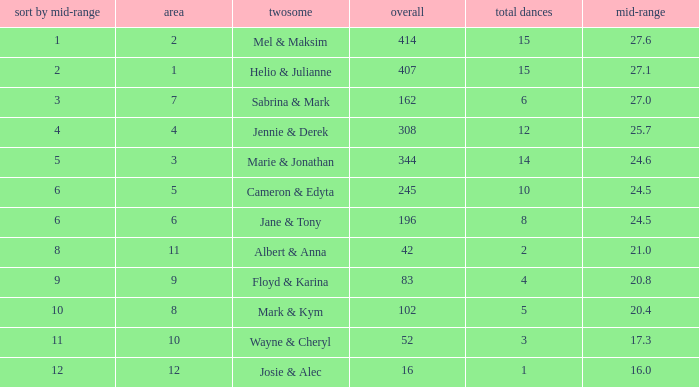What is the rank by average where the total was larger than 245 and the average was 27.1 with fewer than 15 dances? None. 